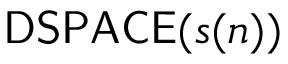Convert formula to latex. <formula><loc_0><loc_0><loc_500><loc_500>{ D S P A C E } ( s ( n ) )</formula> 